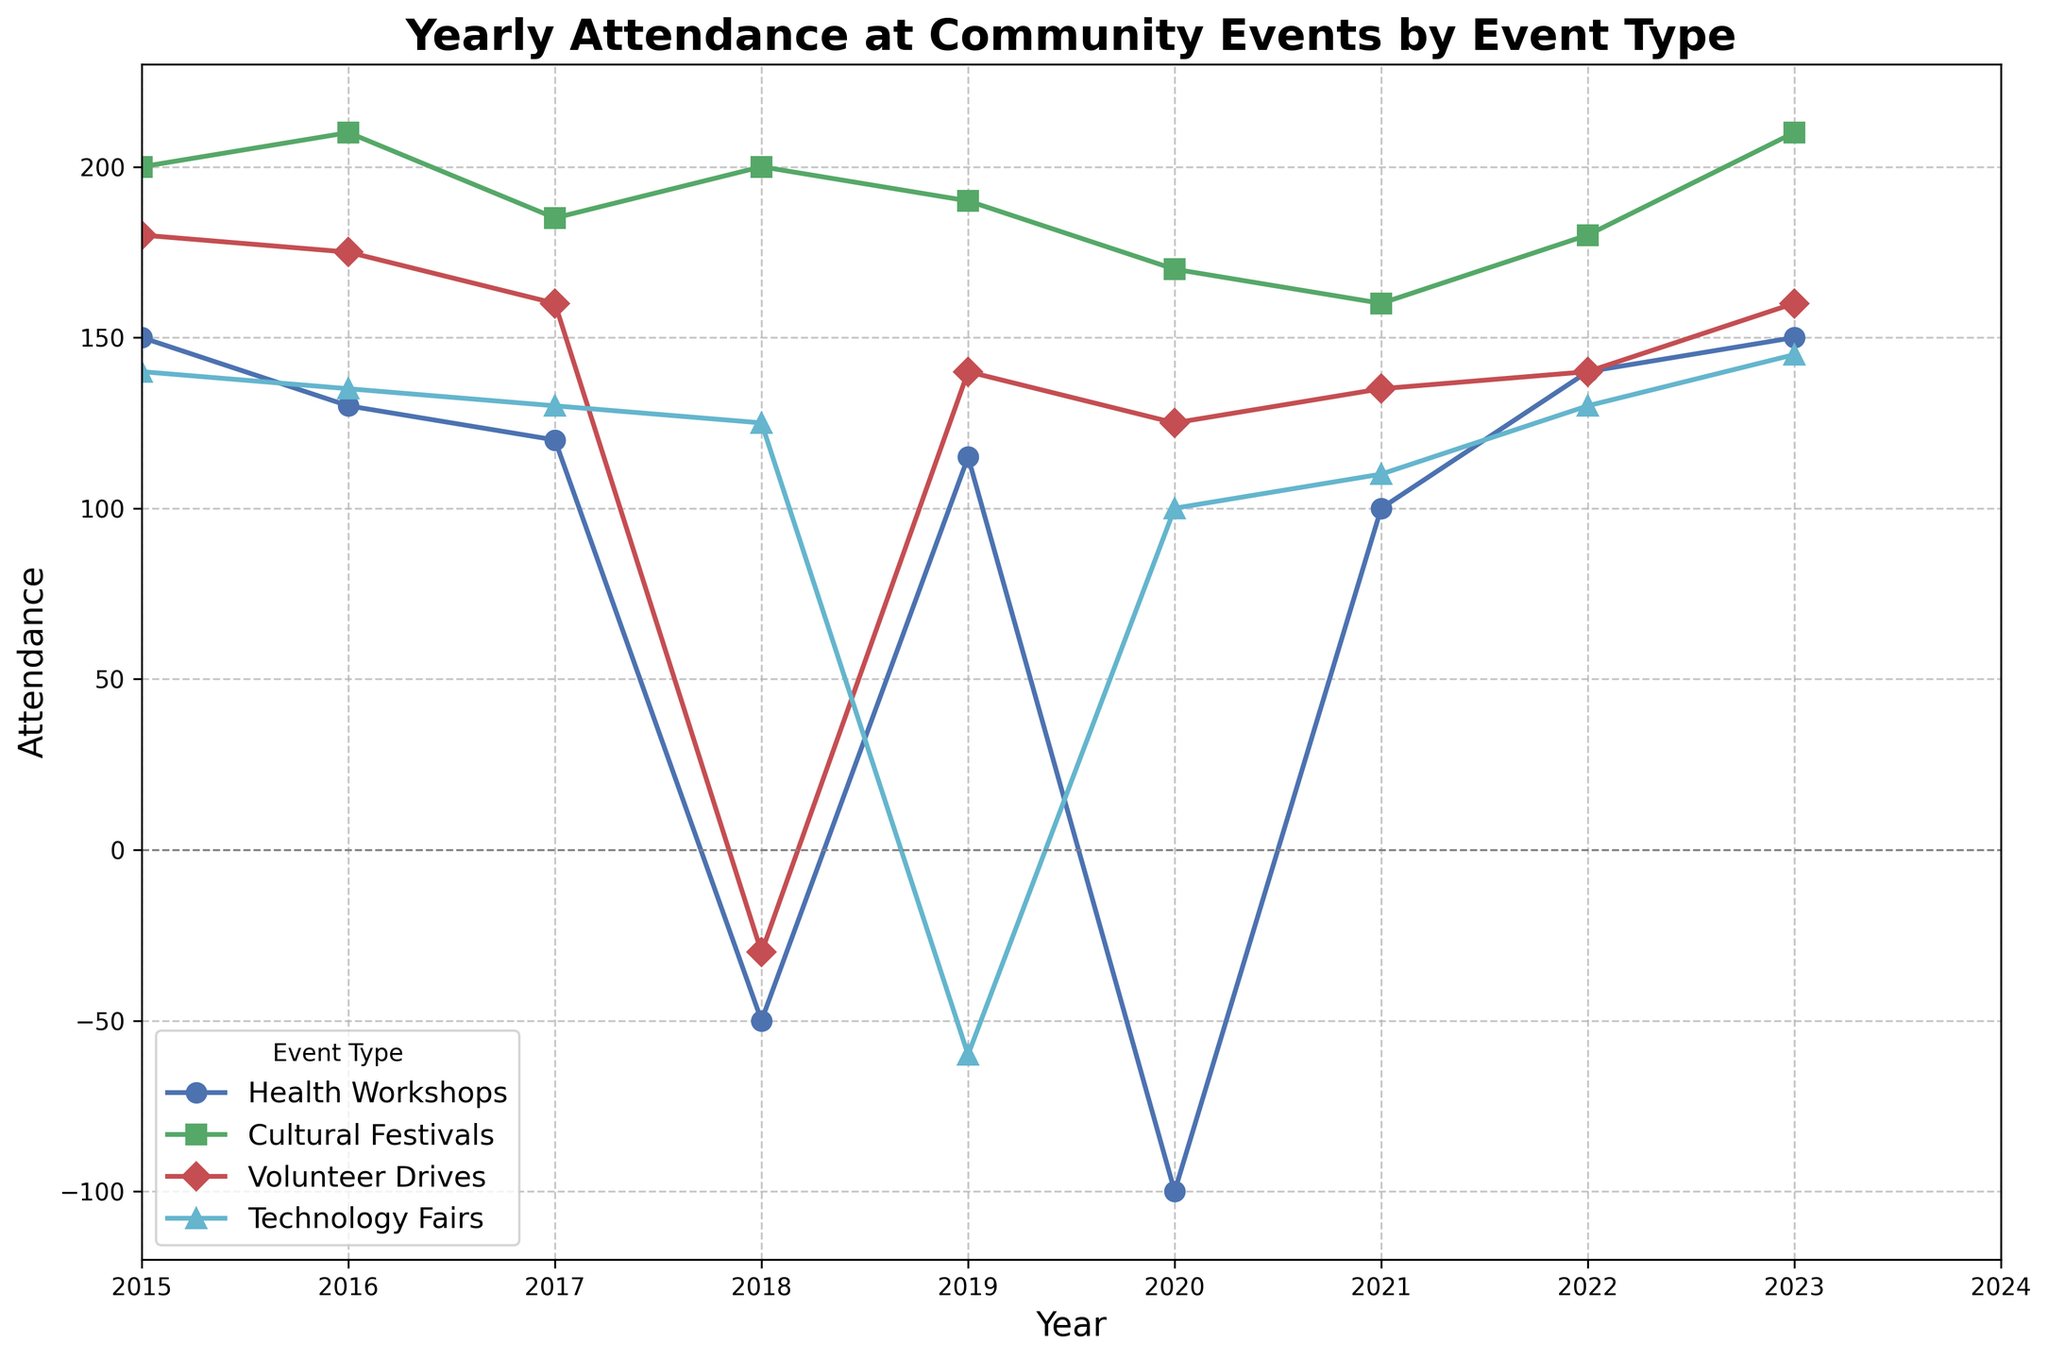What's the trend in attendance for Technology Fairs from 2015 to 2020? The attendance for Technology Fairs starts at 140 in 2015, drops slightly every year, and reaches its lowest point at -60 in 2019 before slight recovery to 100 in 2020.
Answer: Downward Which event type had the highest attendance in 2023? By looking at the line chart for 2023, the highest attendance is for the Cultural Festivals, which is indicated by the color green.
Answer: Cultural Festivals How many times did Health Workshops’ attendance fall into negative values? Observing the line for Health Workshops, marked with blue, it touches negative values twice: in 2018 and 2020.
Answer: 2 Which year had the most significant decline for Volunteer Drives, and what was the attendance? Reviewing the red-marked line for Volunteer Drives, the most significant drop is in 2018 where the attendance falls to -30.
Answer: 2018, -30 What is the average attendance for Cultural Festivals across all years? The attendance numbers for Cultural Festivals are 200, 210, 185, 200, 190, 170, 160, 180, 210. Adding them gives a total of 1705, and there are 9 years, so the average is 1705/9.
Answer: 189.44 Compare the attendance trend of Health Workshops and Technology Fairs in 2020. Which had a better recovery by 2023? Both Health Workshops and Technology Fairs had negative attendance in 2020. Health Workshops improved to 150 by 2023, while Technology Fairs rose to 145. Health Workshops had a more significant recovery.
Answer: Health Workshops What is the combined attendance for all event types in 2019? Adding the attendance values for 2019 for all events: Health Workshops (115) + Cultural Festivals (190) + Volunteer Drives (140) + Technology Fairs (-60), which is 115 + 190 + 140 - 60.
Answer: 385 What is the difference in attendance for Volunteer Drives between 2017 and 2018? In 2017, the attendance for Volunteer Drives was 160, and it dropped to -30 in 2018, so the difference is 160 - (-30).
Answer: 190 What is the least attended event type in 2016 and how much is the attendance? Looking at the data for 2016, Technology Fairs have the lowest attendance with 135.
Answer: Technology Fairs, 135 What was the maximum difference in Yearly Attendance between two successive years for Cultural Festivals? The largest annual change occurred between 2017 and 2018, where it went from 185 to 200, so the difference is 200 - 185.
Answer: 15 